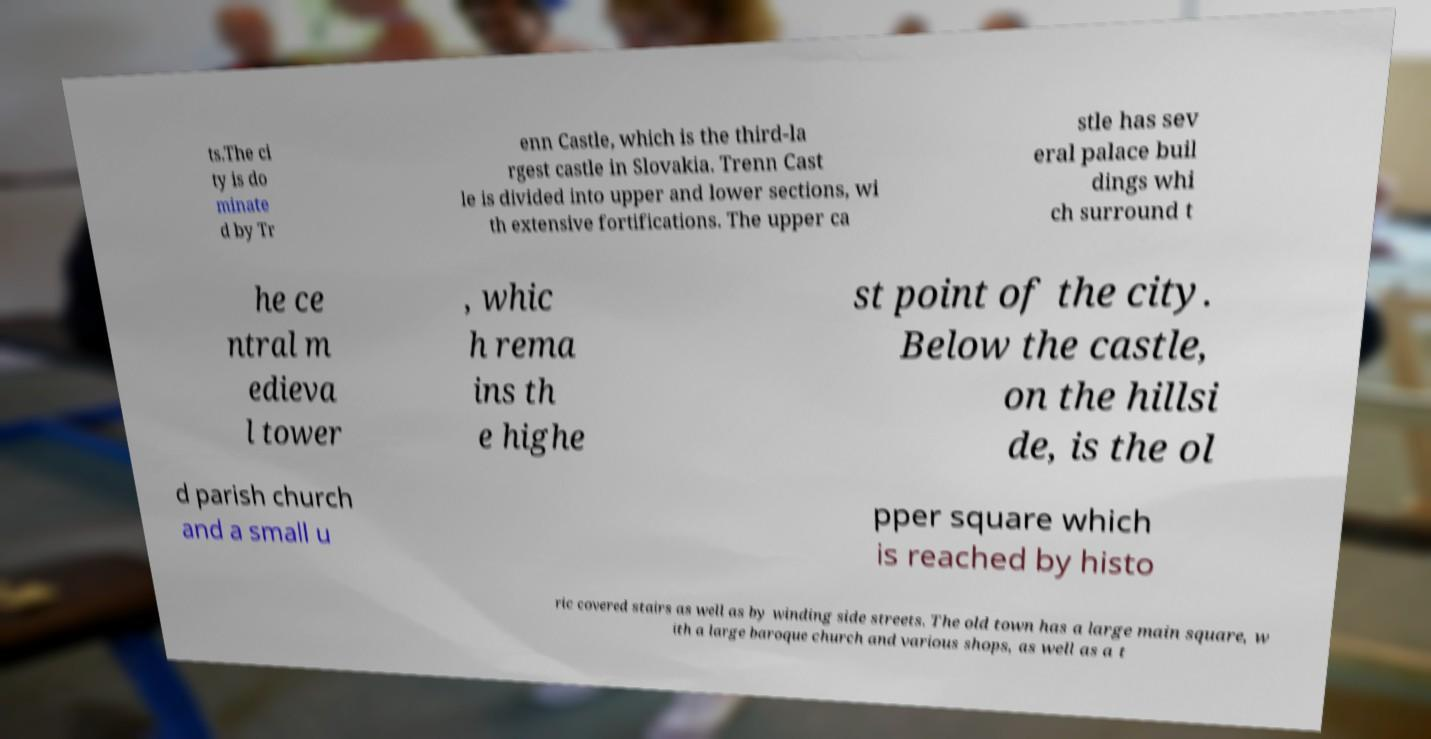What messages or text are displayed in this image? I need them in a readable, typed format. ts.The ci ty is do minate d by Tr enn Castle, which is the third-la rgest castle in Slovakia. Trenn Cast le is divided into upper and lower sections, wi th extensive fortifications. The upper ca stle has sev eral palace buil dings whi ch surround t he ce ntral m edieva l tower , whic h rema ins th e highe st point of the city. Below the castle, on the hillsi de, is the ol d parish church and a small u pper square which is reached by histo ric covered stairs as well as by winding side streets. The old town has a large main square, w ith a large baroque church and various shops, as well as a t 